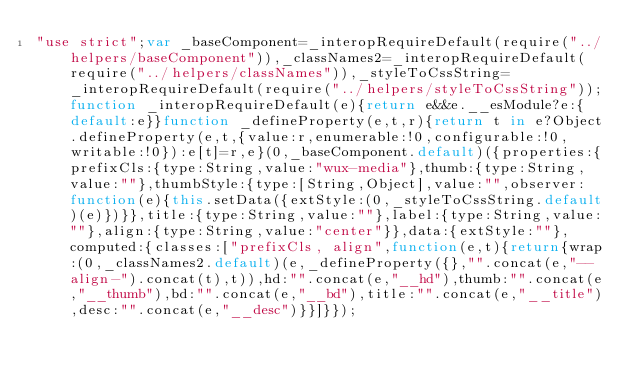Convert code to text. <code><loc_0><loc_0><loc_500><loc_500><_JavaScript_>"use strict";var _baseComponent=_interopRequireDefault(require("../helpers/baseComponent")),_classNames2=_interopRequireDefault(require("../helpers/classNames")),_styleToCssString=_interopRequireDefault(require("../helpers/styleToCssString"));function _interopRequireDefault(e){return e&&e.__esModule?e:{default:e}}function _defineProperty(e,t,r){return t in e?Object.defineProperty(e,t,{value:r,enumerable:!0,configurable:!0,writable:!0}):e[t]=r,e}(0,_baseComponent.default)({properties:{prefixCls:{type:String,value:"wux-media"},thumb:{type:String,value:""},thumbStyle:{type:[String,Object],value:"",observer:function(e){this.setData({extStyle:(0,_styleToCssString.default)(e)})}},title:{type:String,value:""},label:{type:String,value:""},align:{type:String,value:"center"}},data:{extStyle:""},computed:{classes:["prefixCls, align",function(e,t){return{wrap:(0,_classNames2.default)(e,_defineProperty({},"".concat(e,"--align-").concat(t),t)),hd:"".concat(e,"__hd"),thumb:"".concat(e,"__thumb"),bd:"".concat(e,"__bd"),title:"".concat(e,"__title"),desc:"".concat(e,"__desc")}}]}});</code> 